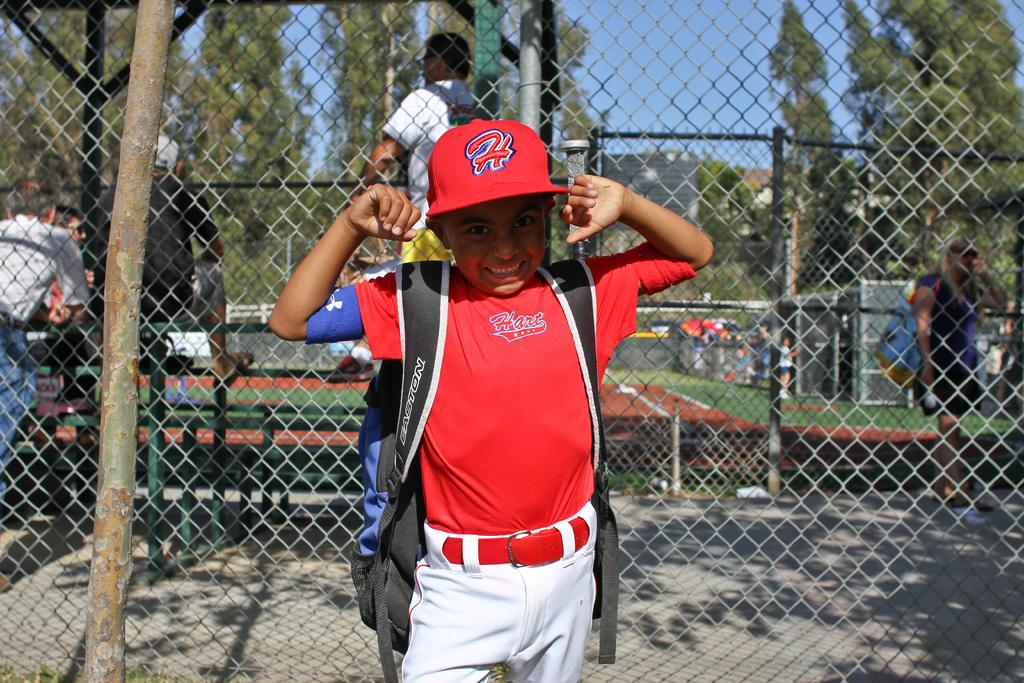<image>
Relay a brief, clear account of the picture shown. a little boy with his backpack wearing his Hart uniform and hat 